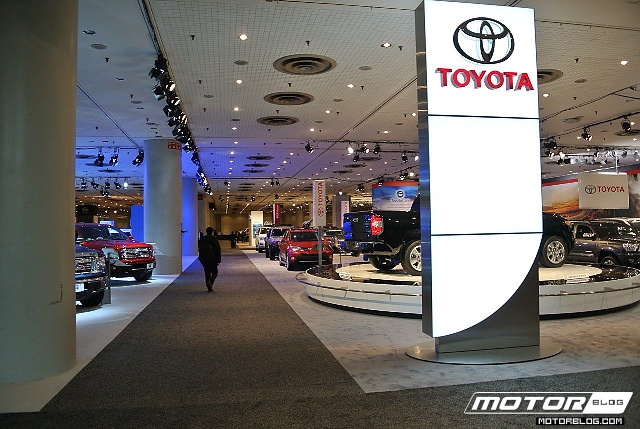Describe the objects in this image and their specific colors. I can see truck in black, gray, darkgray, and ivory tones, car in black and gray tones, truck in black, maroon, gray, and navy tones, car in black, navy, maroon, and gray tones, and truck in black and gray tones in this image. 